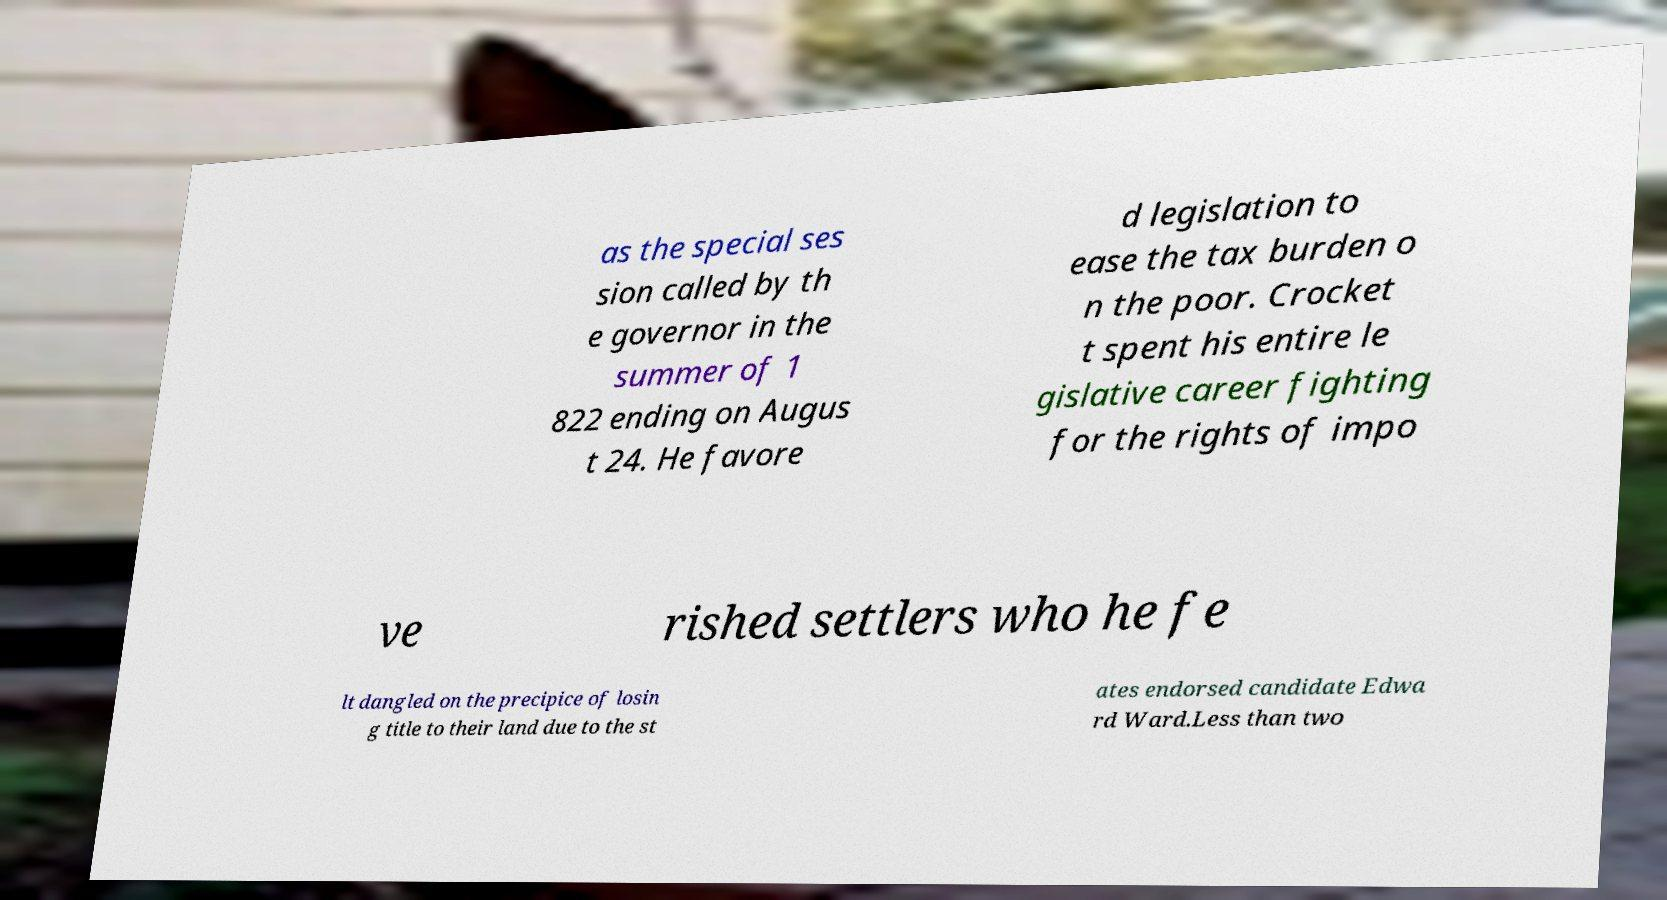Could you assist in decoding the text presented in this image and type it out clearly? as the special ses sion called by th e governor in the summer of 1 822 ending on Augus t 24. He favore d legislation to ease the tax burden o n the poor. Crocket t spent his entire le gislative career fighting for the rights of impo ve rished settlers who he fe lt dangled on the precipice of losin g title to their land due to the st ates endorsed candidate Edwa rd Ward.Less than two 